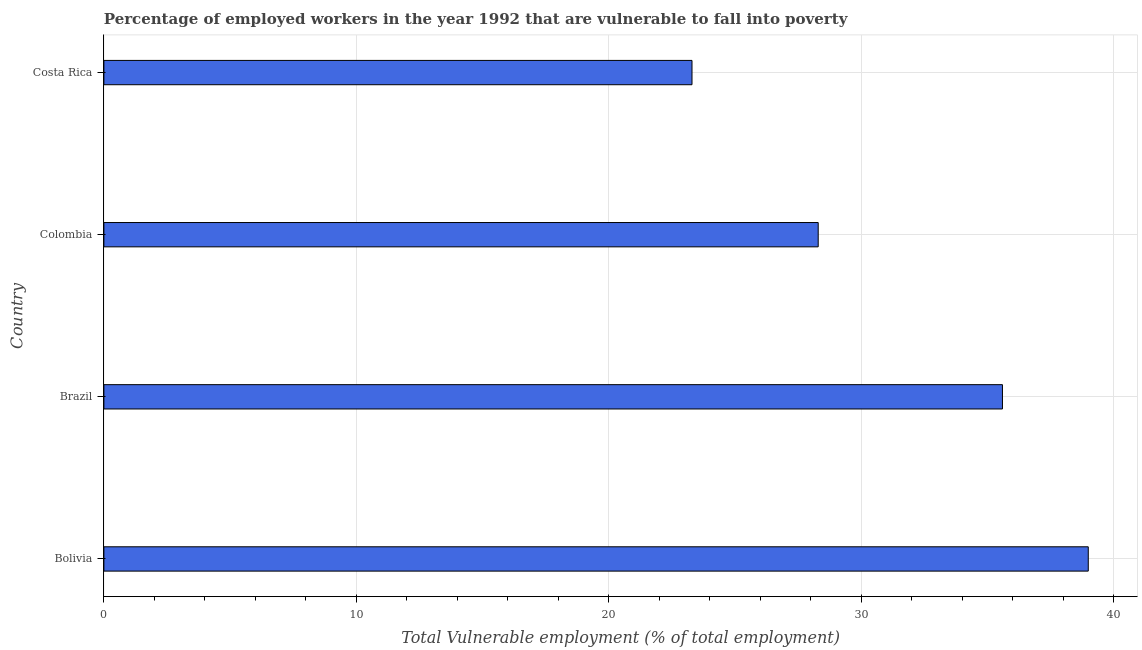Does the graph contain any zero values?
Offer a very short reply. No. What is the title of the graph?
Offer a terse response. Percentage of employed workers in the year 1992 that are vulnerable to fall into poverty. What is the label or title of the X-axis?
Offer a very short reply. Total Vulnerable employment (% of total employment). What is the total vulnerable employment in Costa Rica?
Ensure brevity in your answer.  23.3. Across all countries, what is the maximum total vulnerable employment?
Your response must be concise. 39. Across all countries, what is the minimum total vulnerable employment?
Your answer should be compact. 23.3. What is the sum of the total vulnerable employment?
Your response must be concise. 126.2. What is the difference between the total vulnerable employment in Bolivia and Costa Rica?
Provide a short and direct response. 15.7. What is the average total vulnerable employment per country?
Keep it short and to the point. 31.55. What is the median total vulnerable employment?
Offer a terse response. 31.95. In how many countries, is the total vulnerable employment greater than 28 %?
Offer a terse response. 3. What is the ratio of the total vulnerable employment in Bolivia to that in Colombia?
Provide a short and direct response. 1.38. Is the total vulnerable employment in Colombia less than that in Costa Rica?
Provide a short and direct response. No. In how many countries, is the total vulnerable employment greater than the average total vulnerable employment taken over all countries?
Keep it short and to the point. 2. How many bars are there?
Ensure brevity in your answer.  4. Are all the bars in the graph horizontal?
Your response must be concise. Yes. What is the Total Vulnerable employment (% of total employment) of Brazil?
Ensure brevity in your answer.  35.6. What is the Total Vulnerable employment (% of total employment) of Colombia?
Your response must be concise. 28.3. What is the Total Vulnerable employment (% of total employment) of Costa Rica?
Your answer should be very brief. 23.3. What is the difference between the Total Vulnerable employment (% of total employment) in Bolivia and Costa Rica?
Give a very brief answer. 15.7. What is the difference between the Total Vulnerable employment (% of total employment) in Brazil and Costa Rica?
Your answer should be compact. 12.3. What is the difference between the Total Vulnerable employment (% of total employment) in Colombia and Costa Rica?
Give a very brief answer. 5. What is the ratio of the Total Vulnerable employment (% of total employment) in Bolivia to that in Brazil?
Make the answer very short. 1.1. What is the ratio of the Total Vulnerable employment (% of total employment) in Bolivia to that in Colombia?
Make the answer very short. 1.38. What is the ratio of the Total Vulnerable employment (% of total employment) in Bolivia to that in Costa Rica?
Your answer should be compact. 1.67. What is the ratio of the Total Vulnerable employment (% of total employment) in Brazil to that in Colombia?
Provide a short and direct response. 1.26. What is the ratio of the Total Vulnerable employment (% of total employment) in Brazil to that in Costa Rica?
Keep it short and to the point. 1.53. What is the ratio of the Total Vulnerable employment (% of total employment) in Colombia to that in Costa Rica?
Provide a succinct answer. 1.22. 